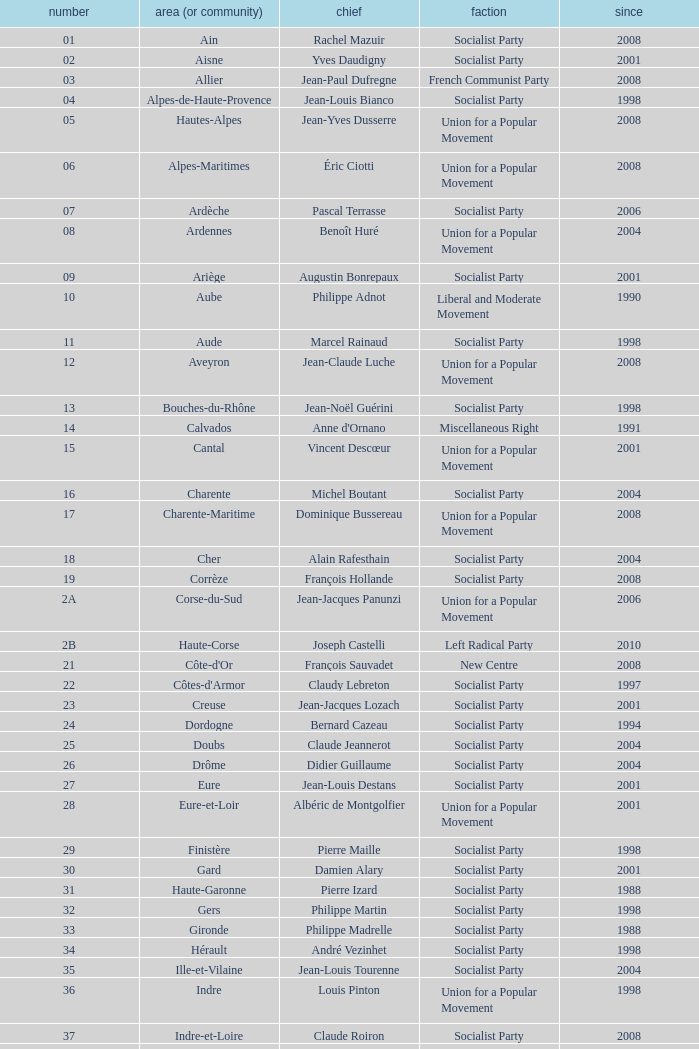Who is the president representing the Creuse department? Jean-Jacques Lozach. 